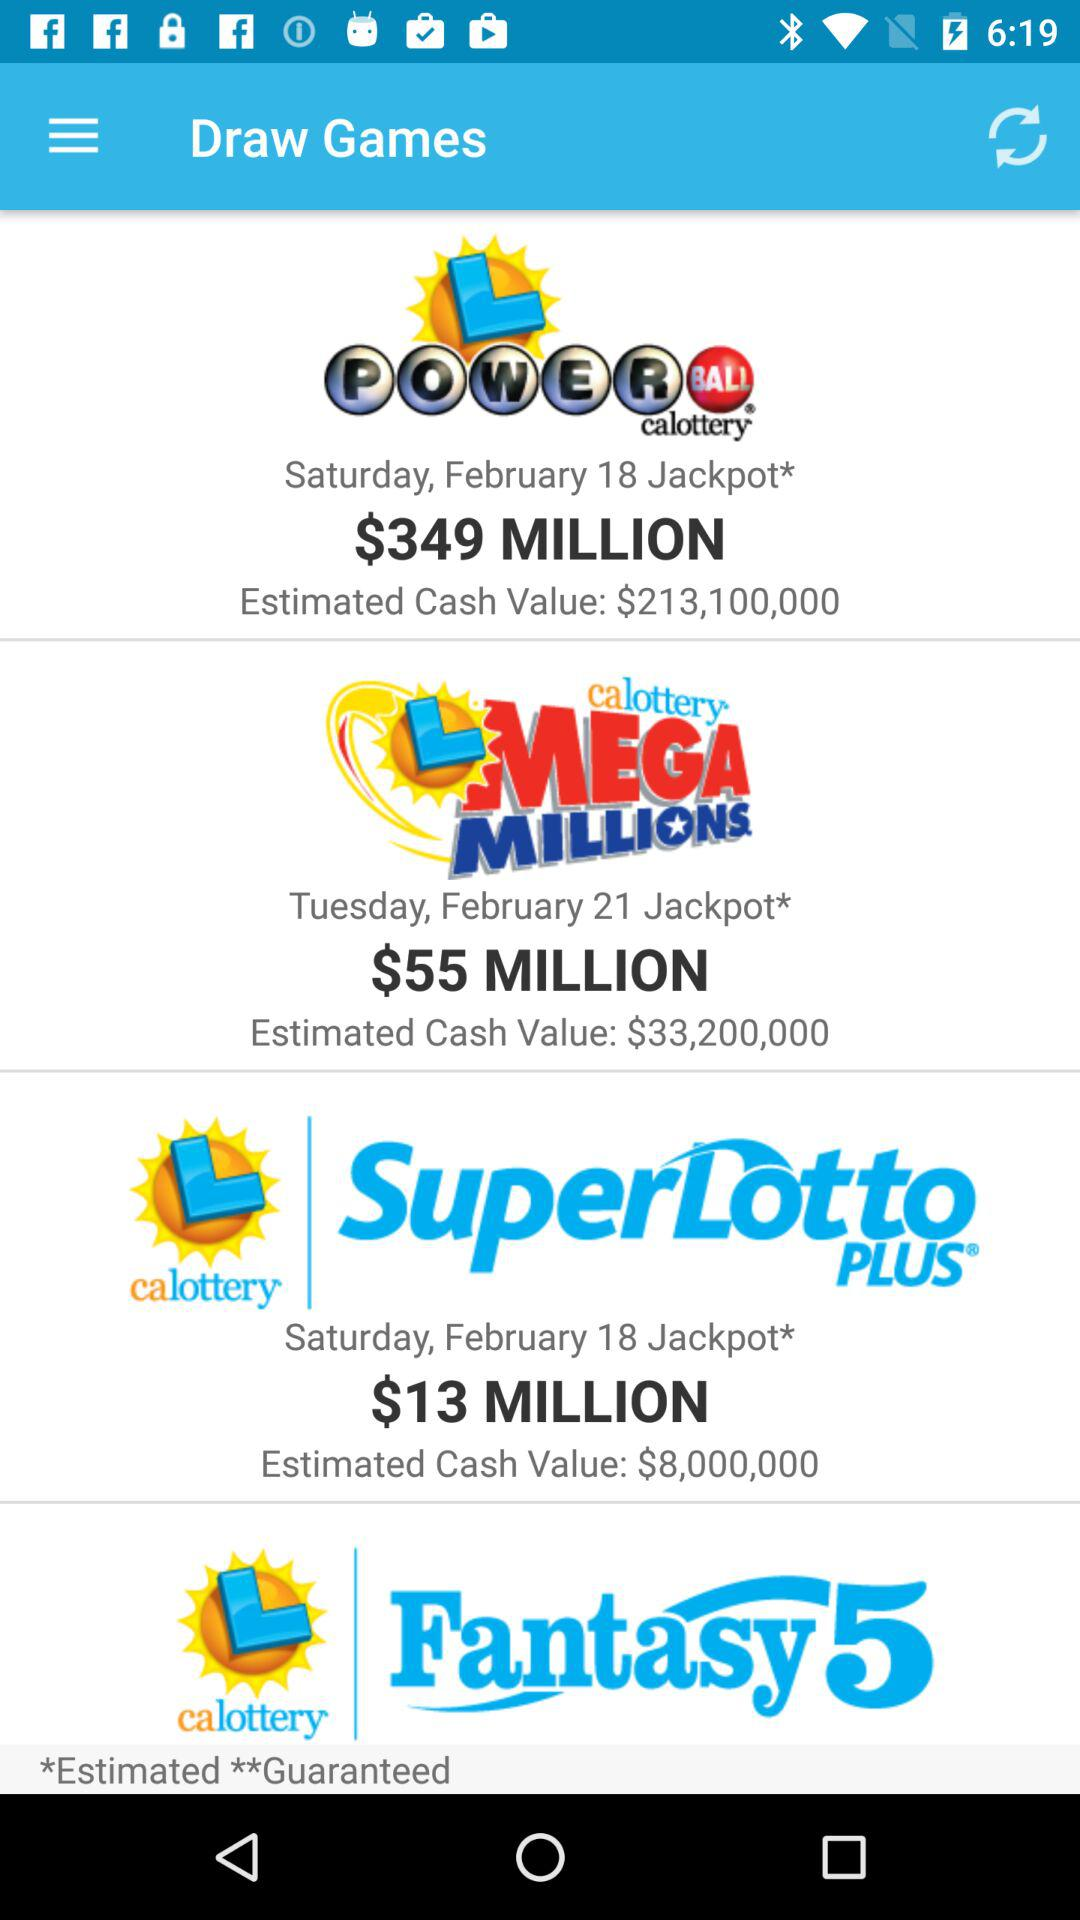What was the estimated cash value of "SuperLotto PLUS"? The estimated cash value was $8,000,000. 